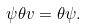Convert formula to latex. <formula><loc_0><loc_0><loc_500><loc_500>\psi \theta v = \theta \psi .</formula> 